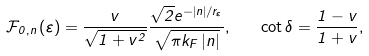Convert formula to latex. <formula><loc_0><loc_0><loc_500><loc_500>\mathcal { F } _ { 0 , n } \left ( \varepsilon \right ) = \frac { v } { \sqrt { 1 + v ^ { 2 } } } \frac { \sqrt { 2 } { e } ^ { - \left | n \right | / r _ { \varepsilon } } } { \sqrt { \pi k _ { F } \left | n \right | } } , \quad \cot \delta = \frac { 1 - v } { 1 + v } ,</formula> 